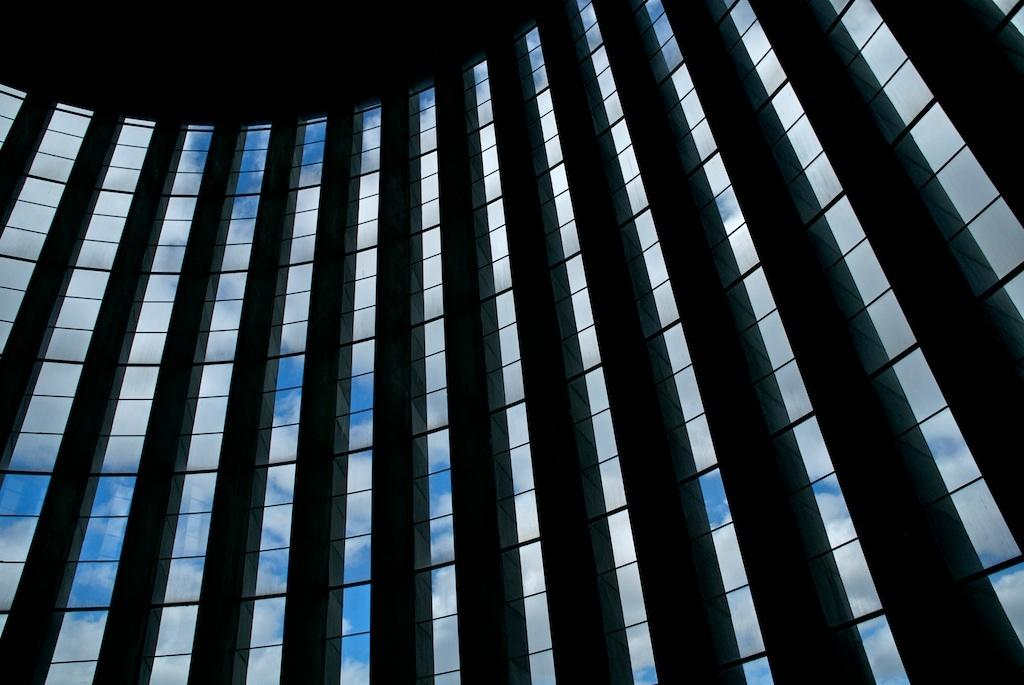What architectural features can be seen in the image? There are pillars in the image. What type of windows are present in the image? There are glass windows in the image. What can be seen through the windows in the image? The sky is visible through the windows. How would you describe the lighting at the top of the image? The top of the image appears to be dark. What type of drug is being sold on the island in the image? There is no island or drug sale present in the image; it features pillars and glass windows with a dark top. 